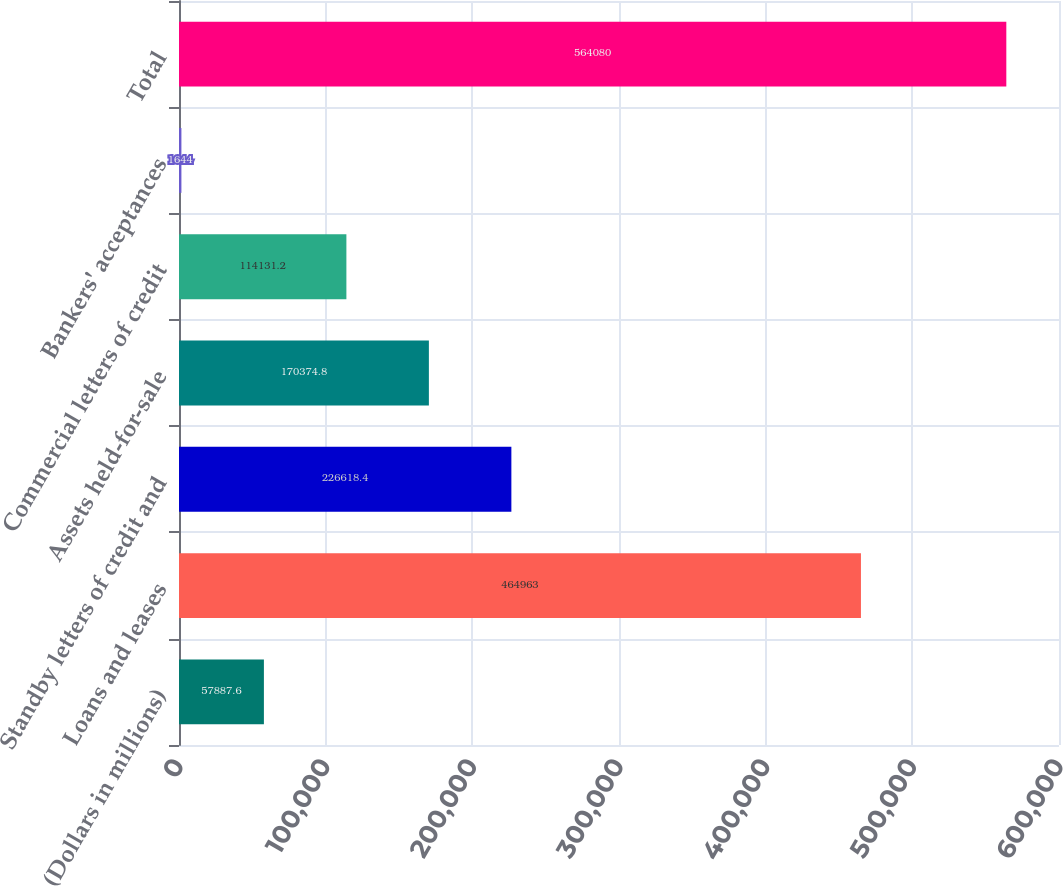Convert chart. <chart><loc_0><loc_0><loc_500><loc_500><bar_chart><fcel>(Dollars in millions)<fcel>Loans and leases<fcel>Standby letters of credit and<fcel>Assets held-for-sale<fcel>Commercial letters of credit<fcel>Bankers' acceptances<fcel>Total<nl><fcel>57887.6<fcel>464963<fcel>226618<fcel>170375<fcel>114131<fcel>1644<fcel>564080<nl></chart> 